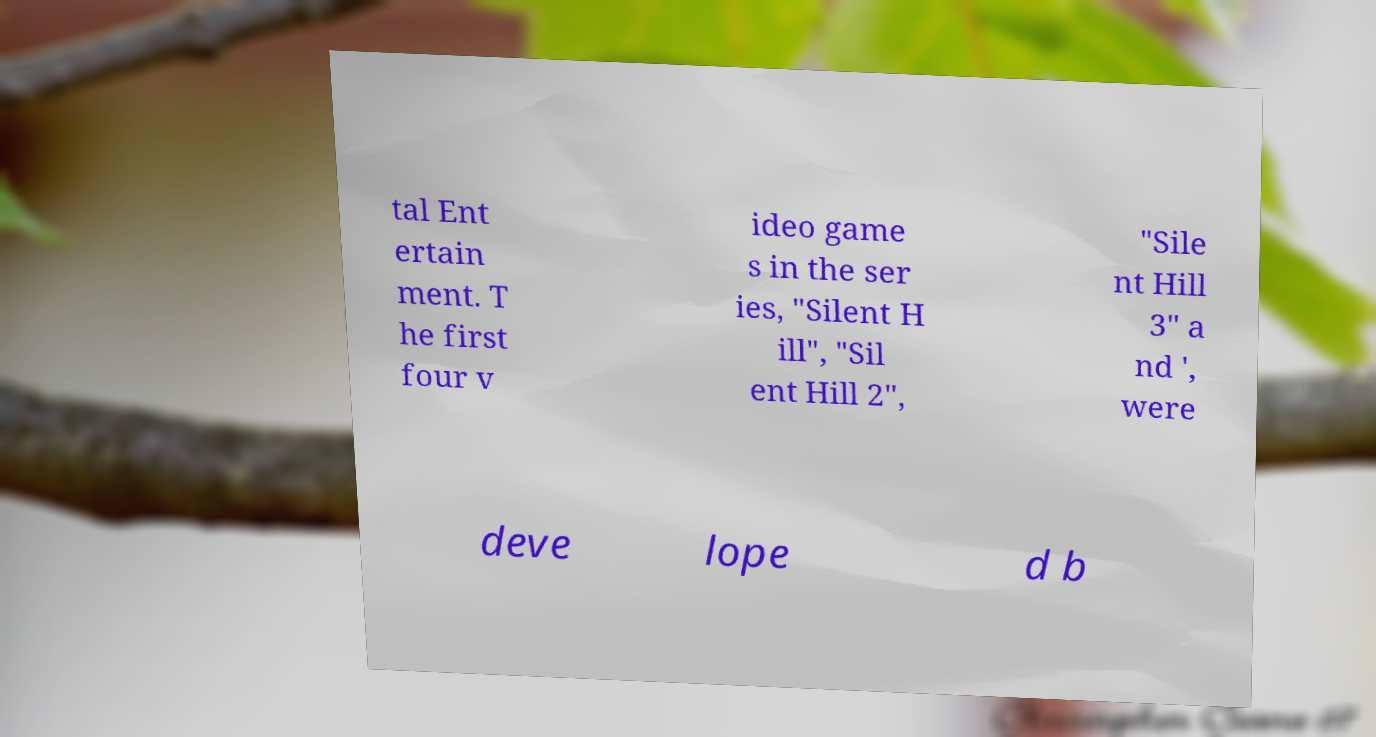Could you assist in decoding the text presented in this image and type it out clearly? tal Ent ertain ment. T he first four v ideo game s in the ser ies, "Silent H ill", "Sil ent Hill 2", "Sile nt Hill 3" a nd ', were deve lope d b 